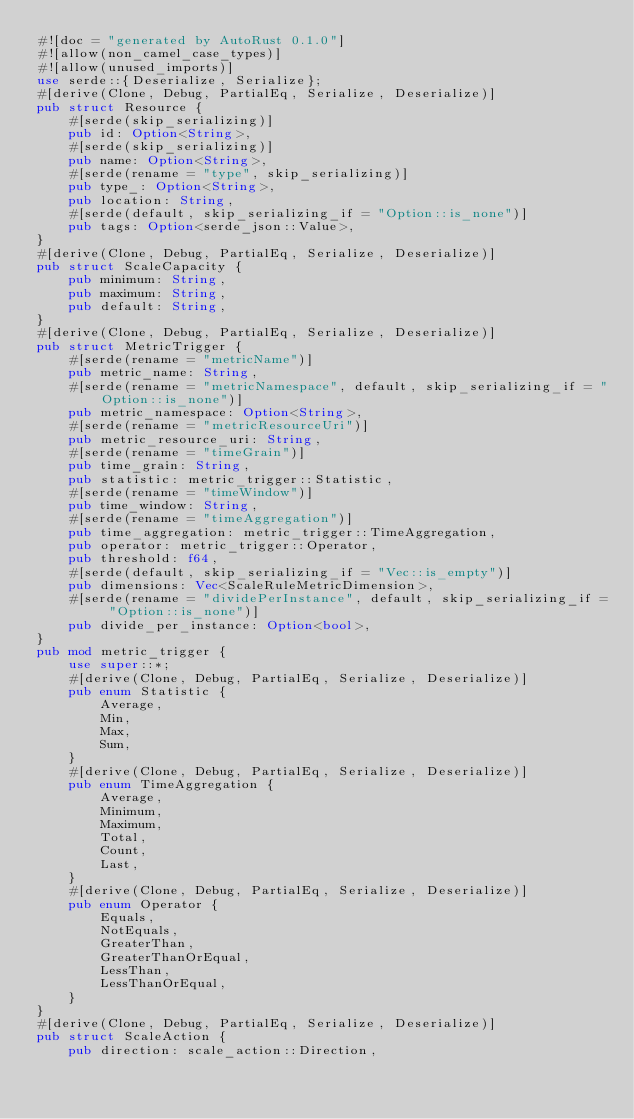Convert code to text. <code><loc_0><loc_0><loc_500><loc_500><_Rust_>#![doc = "generated by AutoRust 0.1.0"]
#![allow(non_camel_case_types)]
#![allow(unused_imports)]
use serde::{Deserialize, Serialize};
#[derive(Clone, Debug, PartialEq, Serialize, Deserialize)]
pub struct Resource {
    #[serde(skip_serializing)]
    pub id: Option<String>,
    #[serde(skip_serializing)]
    pub name: Option<String>,
    #[serde(rename = "type", skip_serializing)]
    pub type_: Option<String>,
    pub location: String,
    #[serde(default, skip_serializing_if = "Option::is_none")]
    pub tags: Option<serde_json::Value>,
}
#[derive(Clone, Debug, PartialEq, Serialize, Deserialize)]
pub struct ScaleCapacity {
    pub minimum: String,
    pub maximum: String,
    pub default: String,
}
#[derive(Clone, Debug, PartialEq, Serialize, Deserialize)]
pub struct MetricTrigger {
    #[serde(rename = "metricName")]
    pub metric_name: String,
    #[serde(rename = "metricNamespace", default, skip_serializing_if = "Option::is_none")]
    pub metric_namespace: Option<String>,
    #[serde(rename = "metricResourceUri")]
    pub metric_resource_uri: String,
    #[serde(rename = "timeGrain")]
    pub time_grain: String,
    pub statistic: metric_trigger::Statistic,
    #[serde(rename = "timeWindow")]
    pub time_window: String,
    #[serde(rename = "timeAggregation")]
    pub time_aggregation: metric_trigger::TimeAggregation,
    pub operator: metric_trigger::Operator,
    pub threshold: f64,
    #[serde(default, skip_serializing_if = "Vec::is_empty")]
    pub dimensions: Vec<ScaleRuleMetricDimension>,
    #[serde(rename = "dividePerInstance", default, skip_serializing_if = "Option::is_none")]
    pub divide_per_instance: Option<bool>,
}
pub mod metric_trigger {
    use super::*;
    #[derive(Clone, Debug, PartialEq, Serialize, Deserialize)]
    pub enum Statistic {
        Average,
        Min,
        Max,
        Sum,
    }
    #[derive(Clone, Debug, PartialEq, Serialize, Deserialize)]
    pub enum TimeAggregation {
        Average,
        Minimum,
        Maximum,
        Total,
        Count,
        Last,
    }
    #[derive(Clone, Debug, PartialEq, Serialize, Deserialize)]
    pub enum Operator {
        Equals,
        NotEquals,
        GreaterThan,
        GreaterThanOrEqual,
        LessThan,
        LessThanOrEqual,
    }
}
#[derive(Clone, Debug, PartialEq, Serialize, Deserialize)]
pub struct ScaleAction {
    pub direction: scale_action::Direction,</code> 